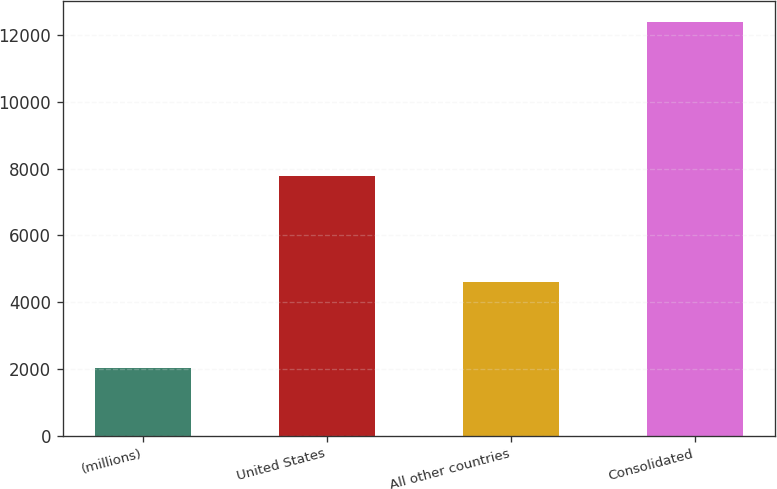Convert chart to OTSL. <chart><loc_0><loc_0><loc_500><loc_500><bar_chart><fcel>(millions)<fcel>United States<fcel>All other countries<fcel>Consolidated<nl><fcel>2010<fcel>7786<fcel>4611<fcel>12397<nl></chart> 